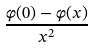Convert formula to latex. <formula><loc_0><loc_0><loc_500><loc_500>\frac { \varphi ( 0 ) - \varphi ( x ) } { x ^ { 2 } }</formula> 